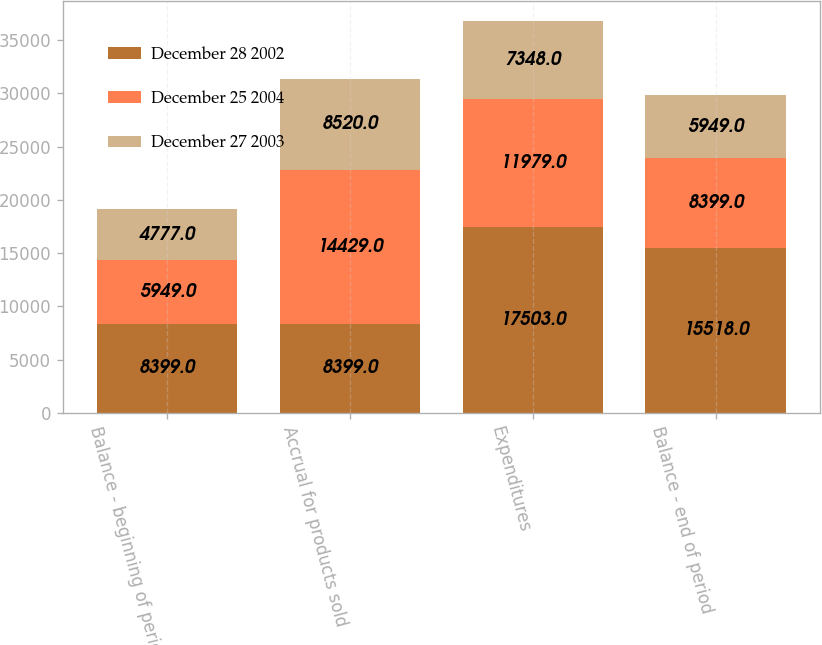Convert chart to OTSL. <chart><loc_0><loc_0><loc_500><loc_500><stacked_bar_chart><ecel><fcel>Balance - beginning of period<fcel>Accrual for products sold<fcel>Expenditures<fcel>Balance - end of period<nl><fcel>December 28 2002<fcel>8399<fcel>8399<fcel>17503<fcel>15518<nl><fcel>December 25 2004<fcel>5949<fcel>14429<fcel>11979<fcel>8399<nl><fcel>December 27 2003<fcel>4777<fcel>8520<fcel>7348<fcel>5949<nl></chart> 